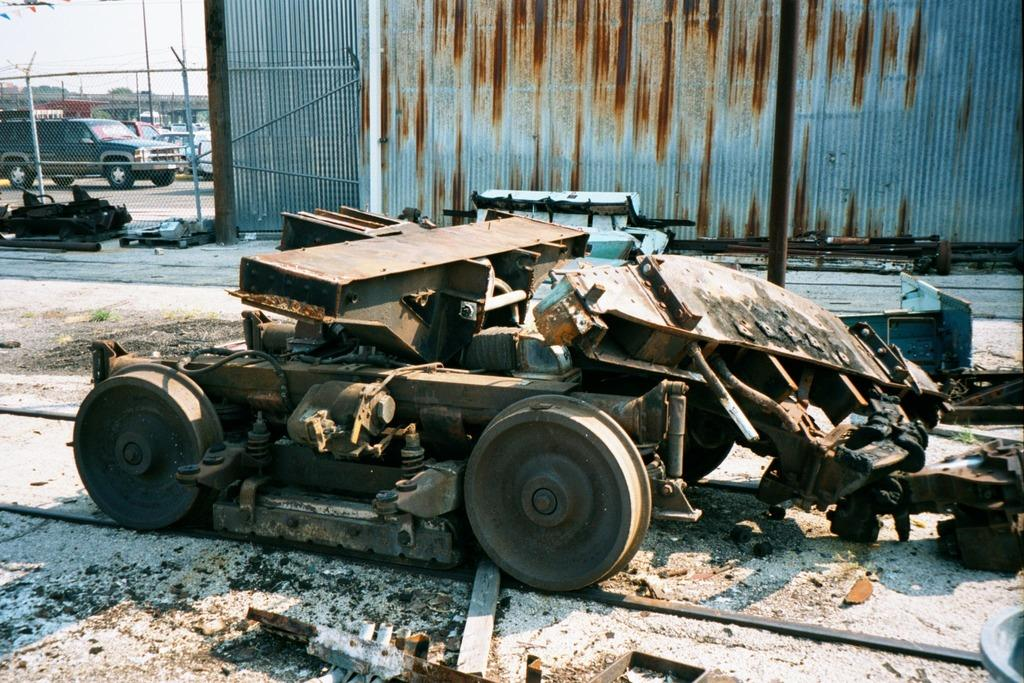What is the main subject of the image? There is a vehicle in the image. What can be seen on the ground in the image? There are objects on the ground in the image. What is visible in the background of the image? There is a fence, a wall, vehicles, trees, and the sky visible in the background of the image. What type of popcorn is being served at the airport in the image? There is no airport or popcorn present in the image. What achievements has the achiever in the image accomplished? There is no achiever or mention of achievements in the image. 